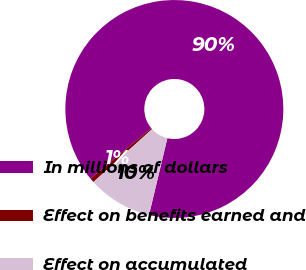Convert chart. <chart><loc_0><loc_0><loc_500><loc_500><pie_chart><fcel>In millions of dollars<fcel>Effect on benefits earned and<fcel>Effect on accumulated<nl><fcel>89.76%<fcel>0.67%<fcel>9.58%<nl></chart> 